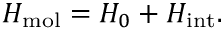Convert formula to latex. <formula><loc_0><loc_0><loc_500><loc_500>H _ { m o l } = H _ { 0 } + H _ { i n t } .</formula> 